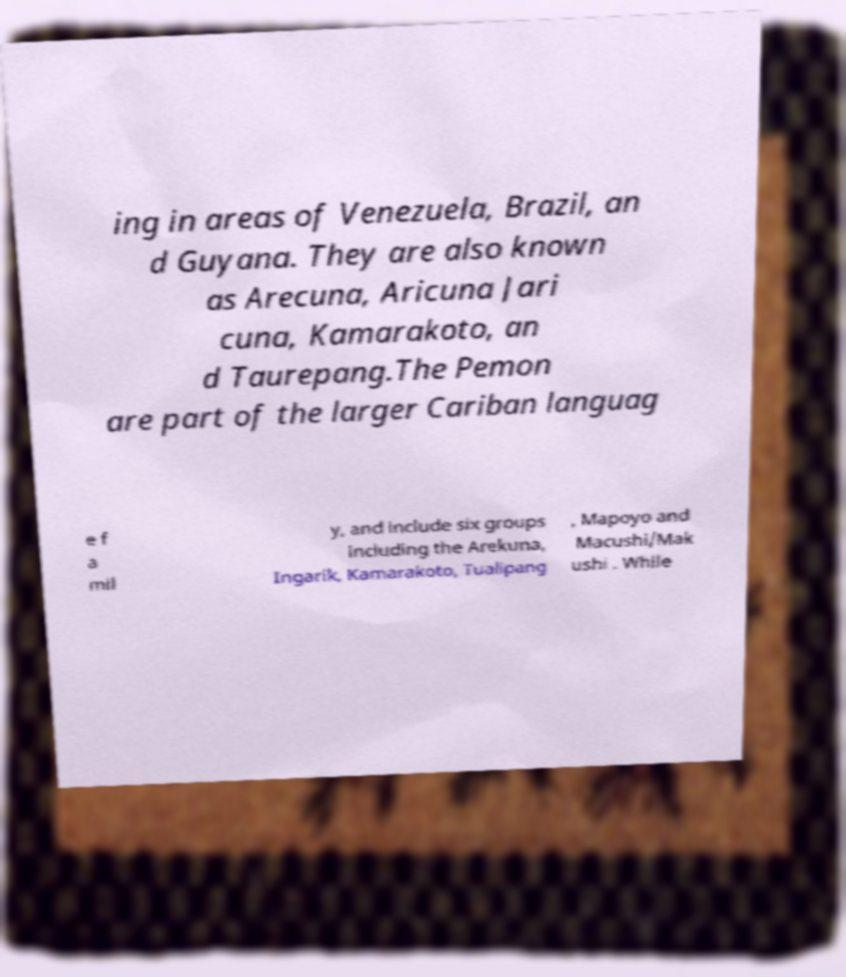Could you assist in decoding the text presented in this image and type it out clearly? ing in areas of Venezuela, Brazil, an d Guyana. They are also known as Arecuna, Aricuna Jari cuna, Kamarakoto, an d Taurepang.The Pemon are part of the larger Cariban languag e f a mil y, and include six groups including the Arekuna, Ingarik, Kamarakoto, Tualipang , Mapoyo and Macushi/Mak ushi . While 